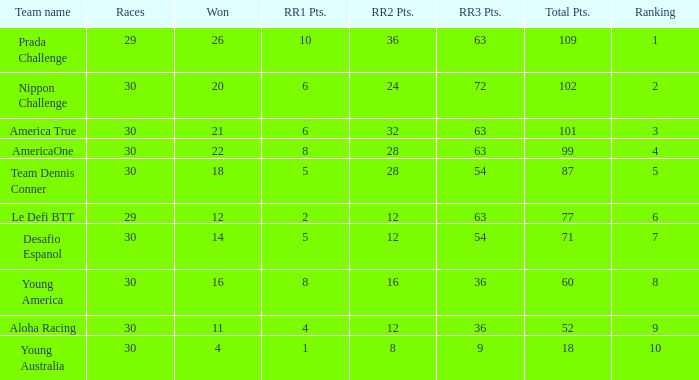Name the total number of rr2 pts for won being 11 1.0. 